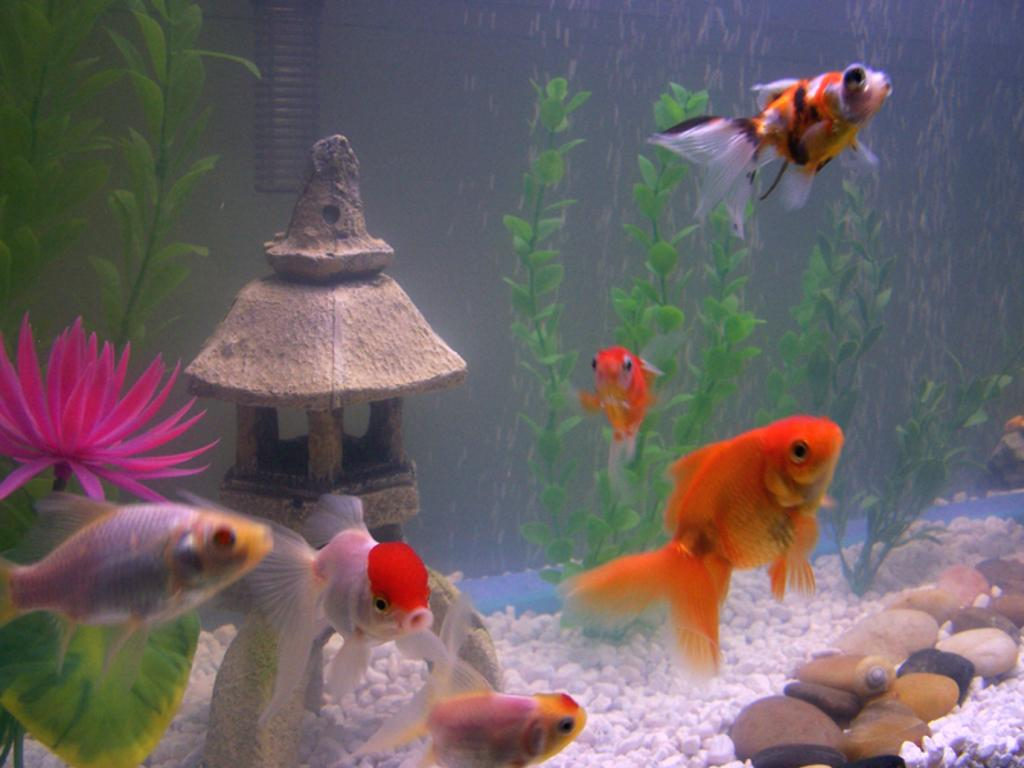What type of environment is depicted in the image? The image is of an aquarium. What creatures can be seen in the aquarium? There are fishes in the aquarium. What other elements are present in the aquarium besides the fishes? There are pebbles, plants, a flower, and a small house in the aquarium. What type of cushion can be seen in the image? There is no cushion present in the image; it is a picture of an aquarium with various elements inside. 